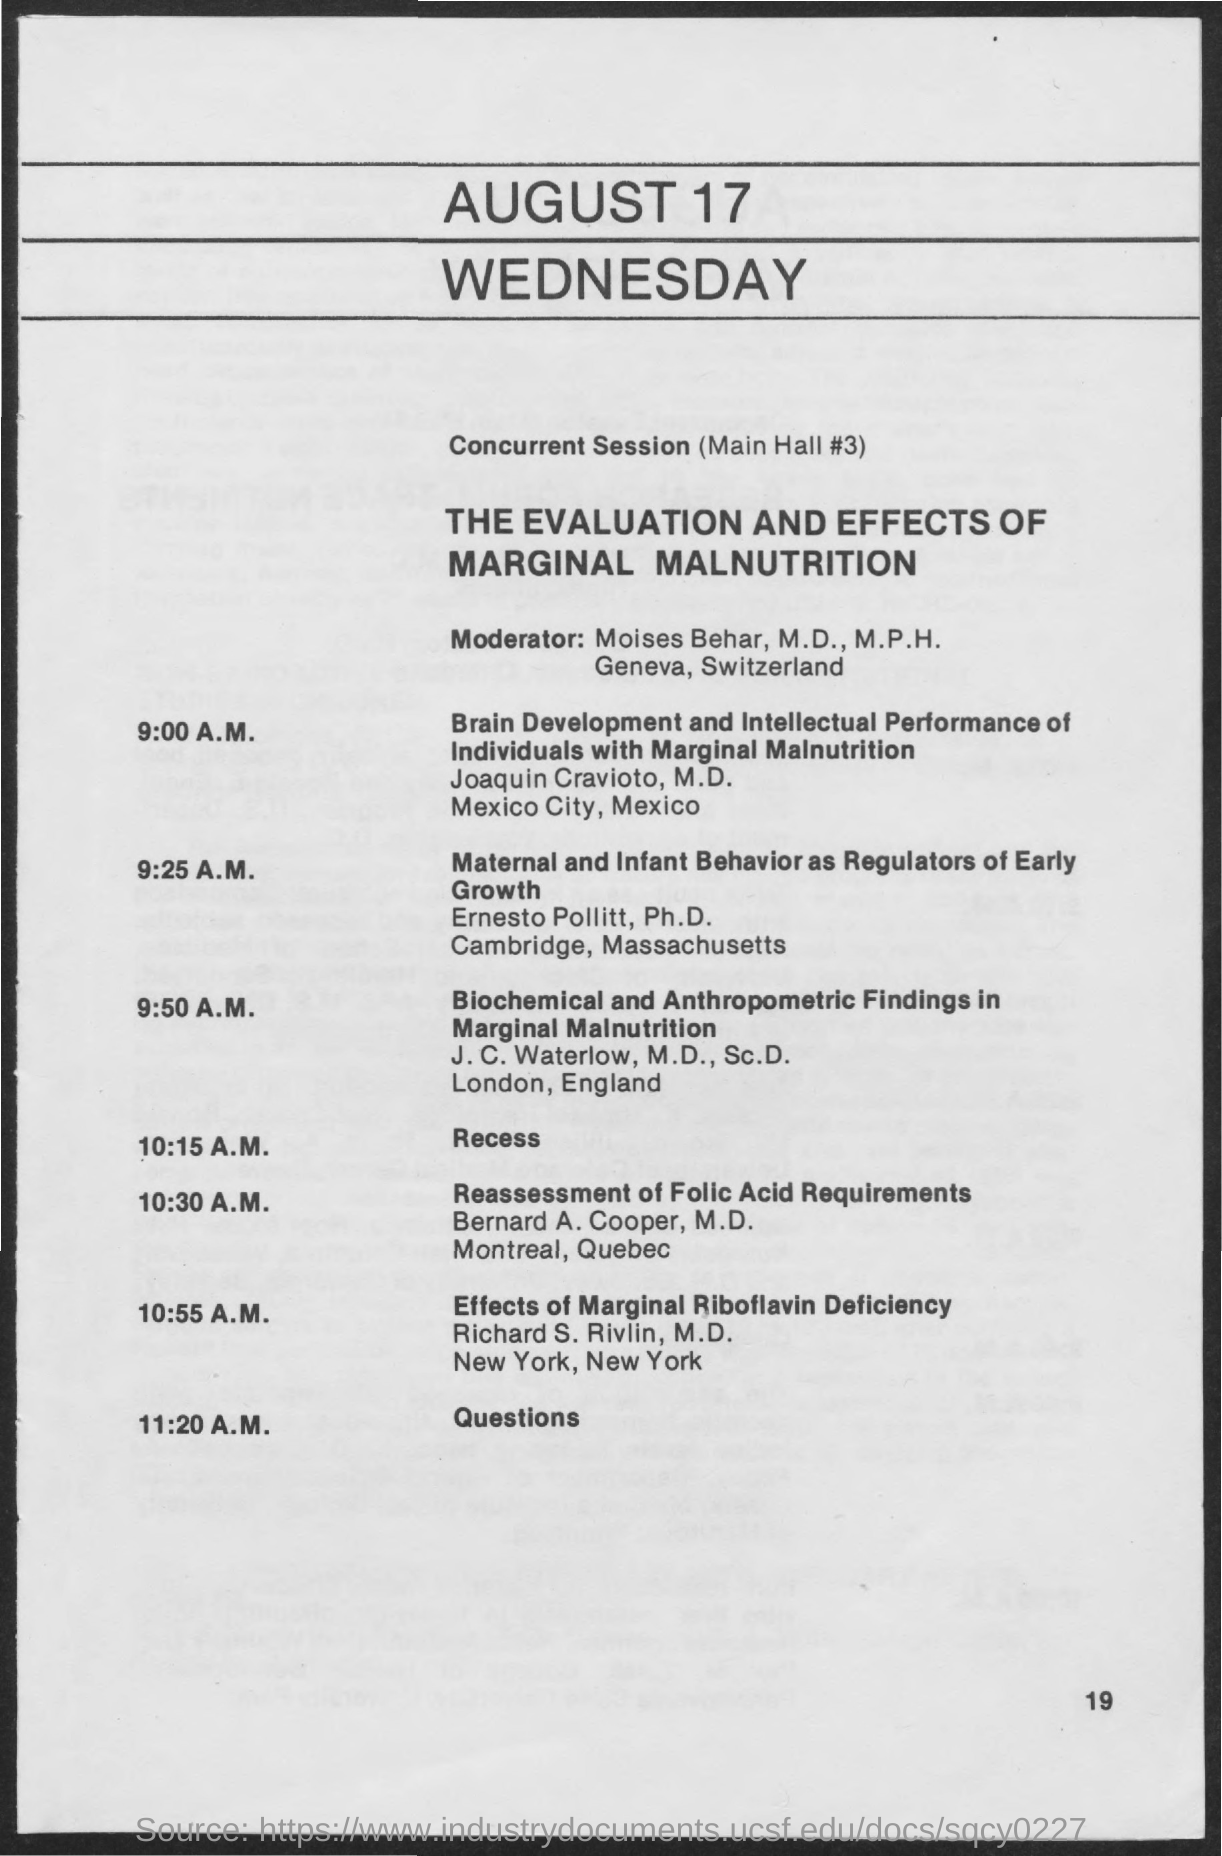Give some essential details in this illustration. The recess will take place at 10:15 A.M.. The date on the document is August 17. 